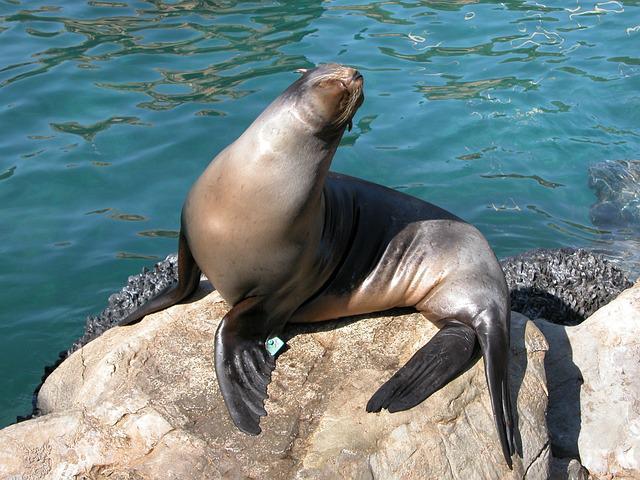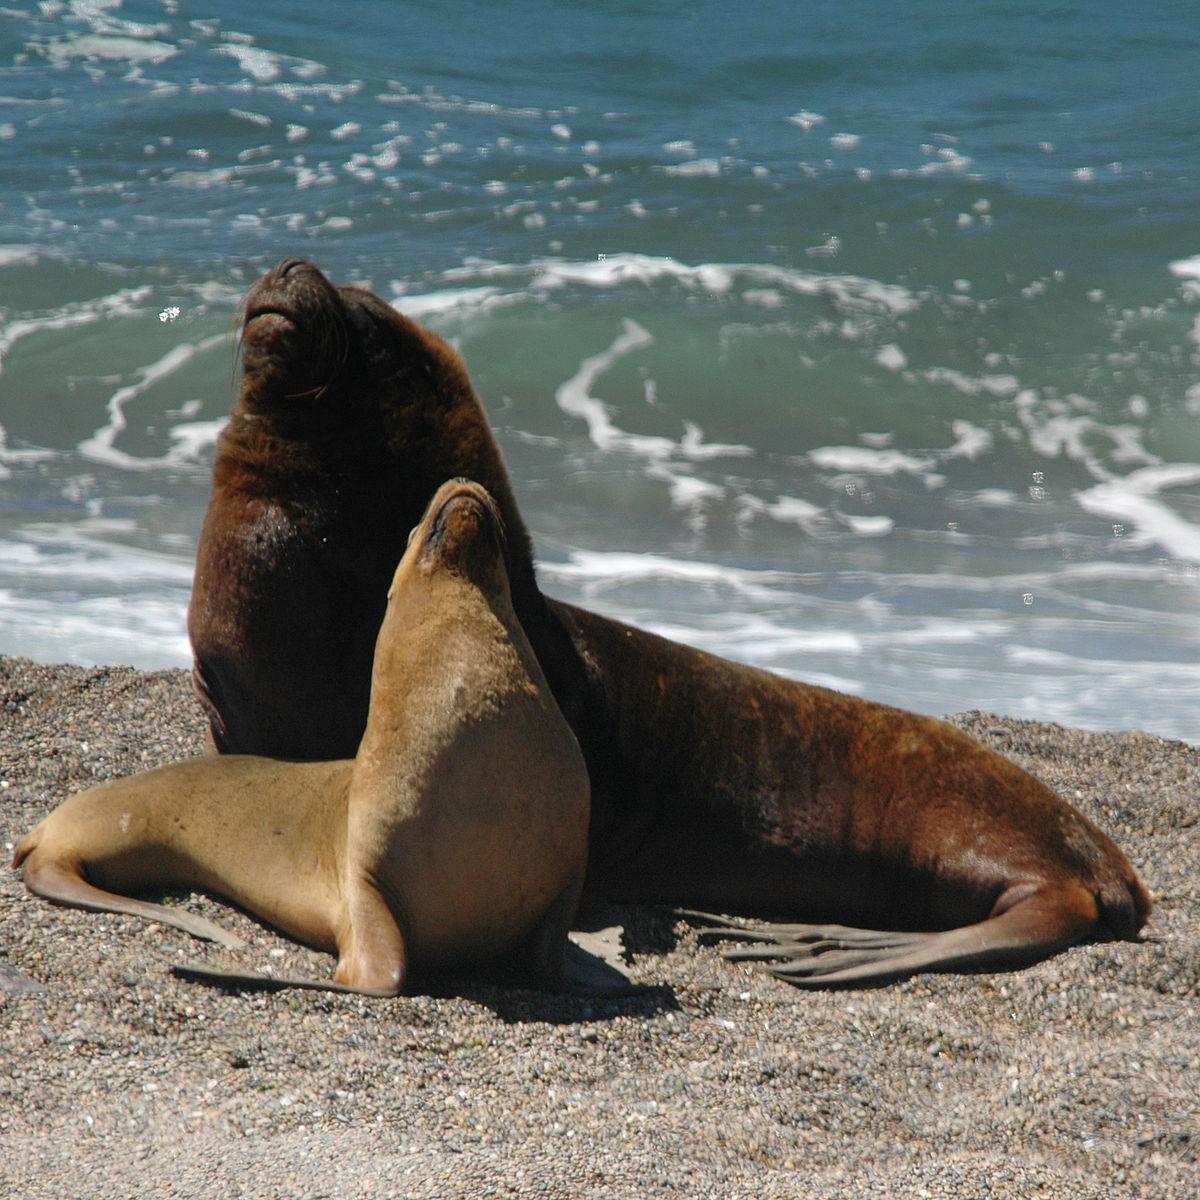The first image is the image on the left, the second image is the image on the right. For the images displayed, is the sentence "One image shows exactly two seals, which are of different sizes." factually correct? Answer yes or no. Yes. The first image is the image on the left, the second image is the image on the right. For the images displayed, is the sentence "One of the images shows exactly two sea lions." factually correct? Answer yes or no. Yes. 